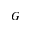Convert formula to latex. <formula><loc_0><loc_0><loc_500><loc_500>G</formula> 